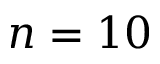<formula> <loc_0><loc_0><loc_500><loc_500>n = 1 0</formula> 